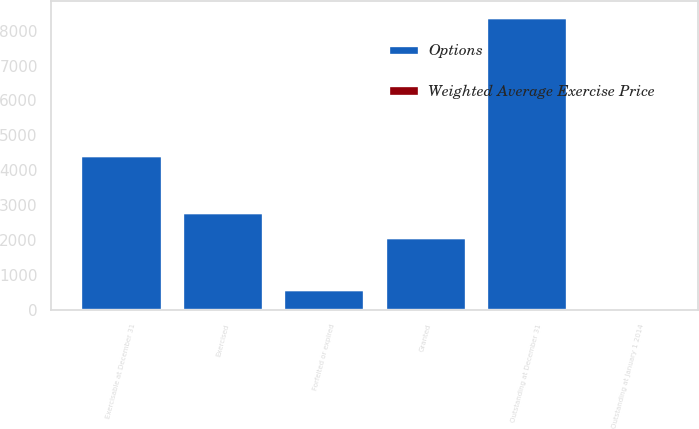<chart> <loc_0><loc_0><loc_500><loc_500><stacked_bar_chart><ecel><fcel>Outstanding at January 1 2014<fcel>Granted<fcel>Exercised<fcel>Forfeited or expired<fcel>Outstanding at December 31<fcel>Exercisable at December 31<nl><fcel>Options<fcel>41.23<fcel>2099<fcel>2798<fcel>597<fcel>8378<fcel>4451<nl><fcel>Weighted Average Exercise Price<fcel>35.98<fcel>41.23<fcel>35.85<fcel>37.6<fcel>37.22<fcel>36.05<nl></chart> 